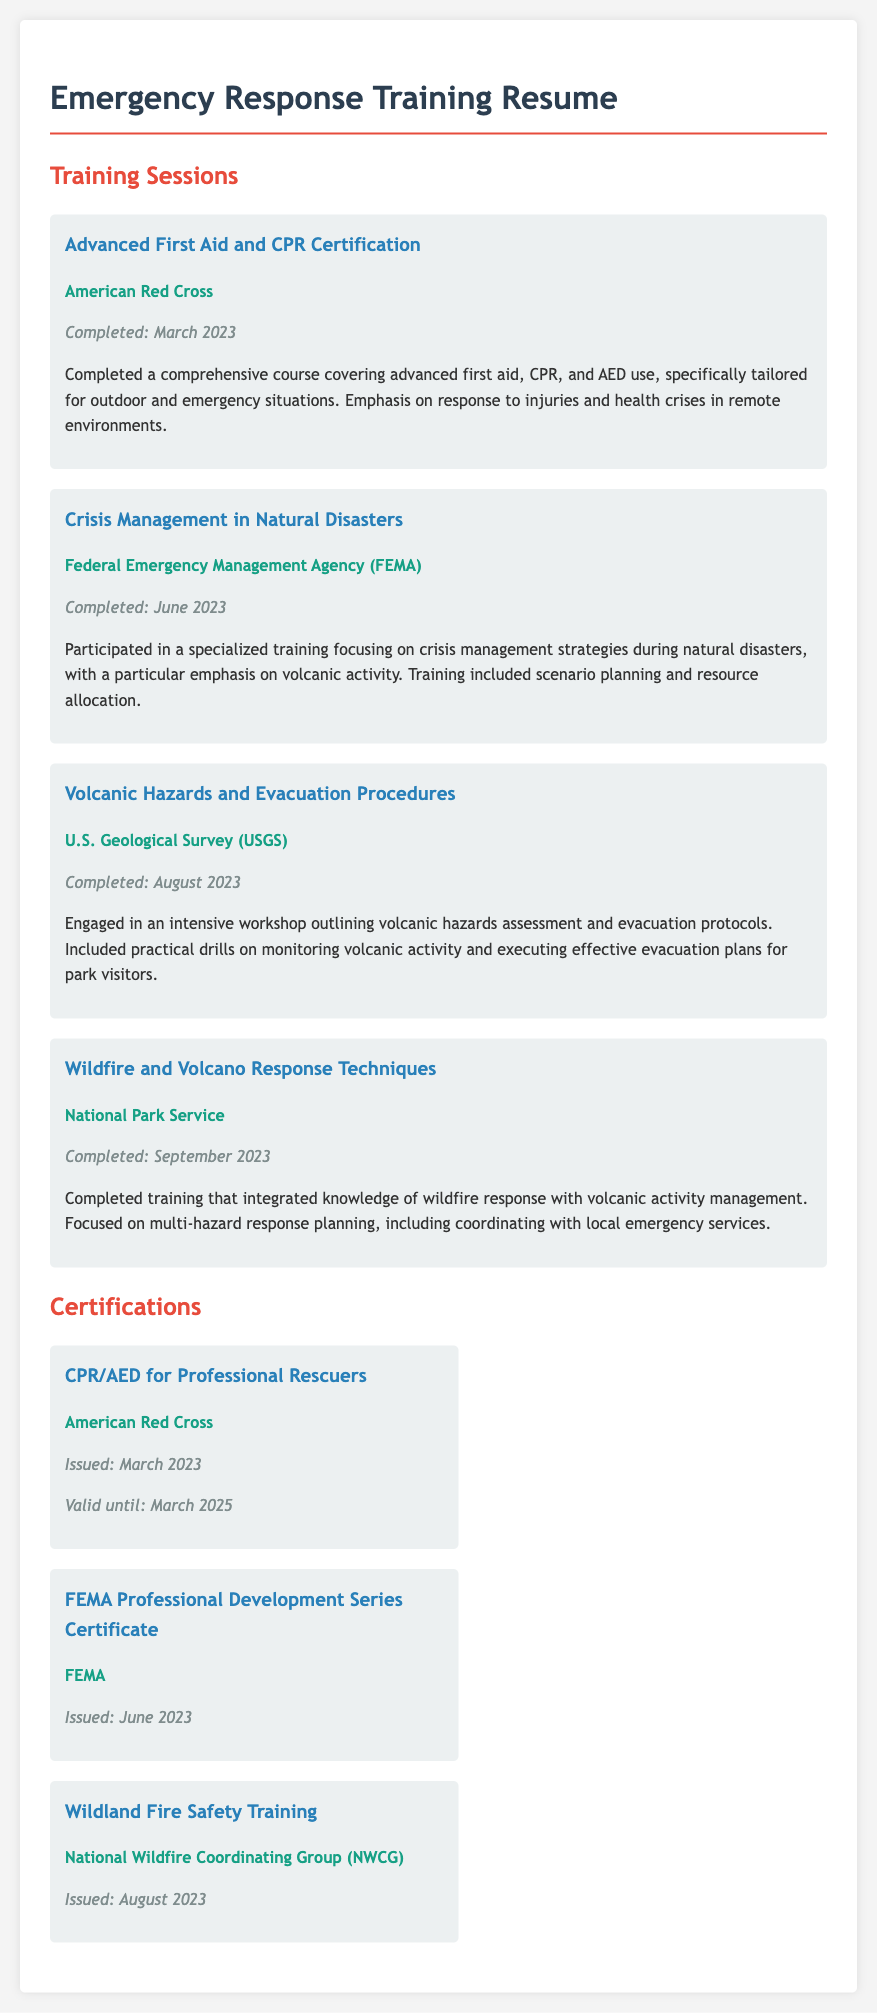What organization provided the Advanced First Aid and CPR Certification? The organization that provided the certification is mentioned in the first training session.
Answer: American Red Cross When was the Crisis Management in Natural Disasters training completed? The completion date is specified in the second training session details.
Answer: June 2023 What certification is valid until March 2025? The certification mentioned has a validity period provided in the Certifications section of the document.
Answer: CPR/AED for Professional Rescuers Which training session focused on volcanic hazards assessment? This information is based on the description of the third training session listed in the document.
Answer: Volcanic Hazards and Evacuation Procedures How many training sessions are listed in the document? The number of training sessions can be found by counting the individual training items presented.
Answer: Four What is the issuing organization of the Wildland Fire Safety Training? The issuing organization is found in the certifications section regarding the specific certification.
Answer: National Wildfire Coordinating Group (NWCG) What month and year was the Volcanic Hazards and Evacuation Procedures training completed? The month and year can be derived from the date stated in the third training session.
Answer: August 2023 Which organization emphasizes crisis management strategies during natural disasters? This information comes from the organization listed for the second training session in the document.
Answer: Federal Emergency Management Agency (FEMA) What is the color used for the headings of the certifications section? The document describes the design elements of the certification section.
Answer: Red 